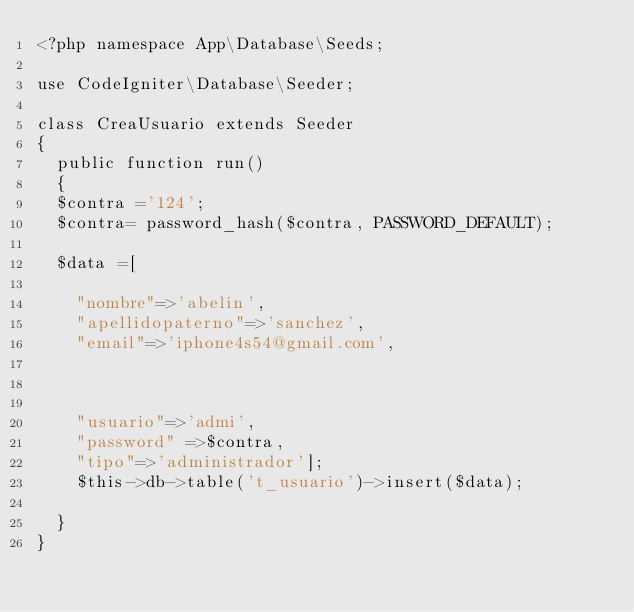Convert code to text. <code><loc_0><loc_0><loc_500><loc_500><_PHP_><?php namespace App\Database\Seeds;

use CodeIgniter\Database\Seeder;

class CreaUsuario extends Seeder
{
	public function run()
	{
	$contra ='124';
	$contra= password_hash($contra, PASSWORD_DEFAULT);
	
	$data =[

		"nombre"=>'abelin',
		"apellidopaterno"=>'sanchez',
		"email"=>'iphone4s54@gmail.com',



		"usuario"=>'admi',
		"password" =>$contra,
		"tipo"=>'administrador'];
		$this->db->table('t_usuario')->insert($data);
	
	}
}
</code> 